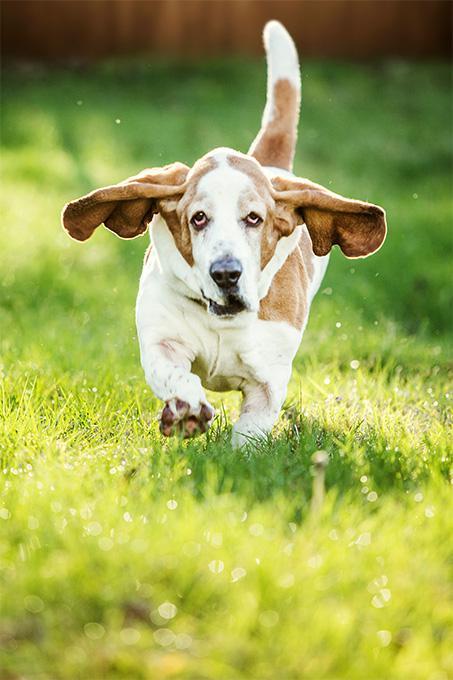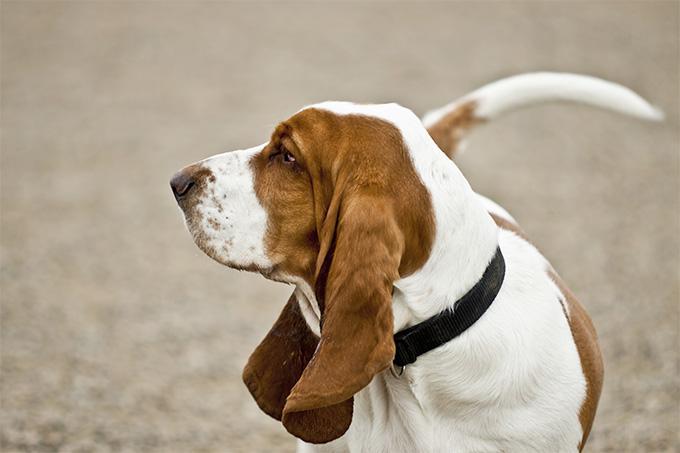The first image is the image on the left, the second image is the image on the right. For the images shown, is this caption "There are at least three dogs outside in the grass." true? Answer yes or no. No. The first image is the image on the left, the second image is the image on the right. For the images displayed, is the sentence "An image shows at least one camera-facing basset hound sitting upright in the grass." factually correct? Answer yes or no. No. 